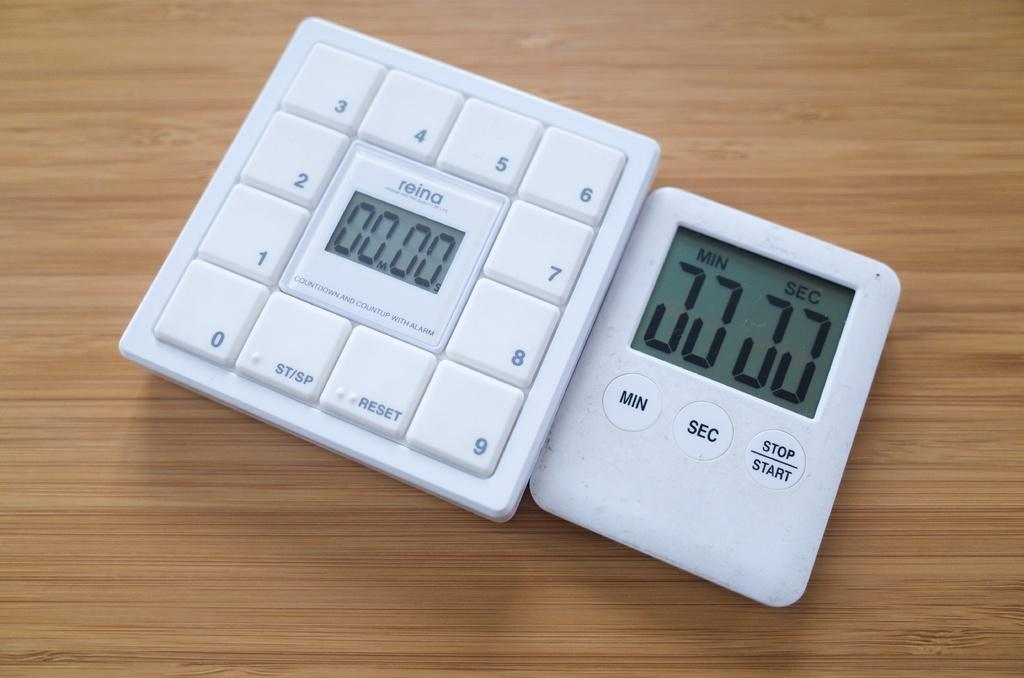<image>
Create a compact narrative representing the image presented. a Reina digital device has a read out of 00.00 